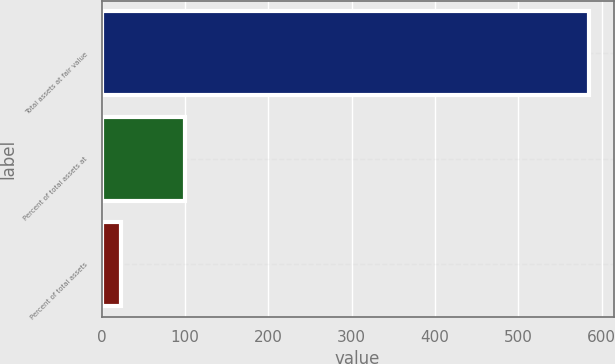Convert chart to OTSL. <chart><loc_0><loc_0><loc_500><loc_500><bar_chart><fcel>Total assets at fair value<fcel>Percent of total assets at<fcel>Percent of total assets<nl><fcel>584.9<fcel>100<fcel>22.9<nl></chart> 